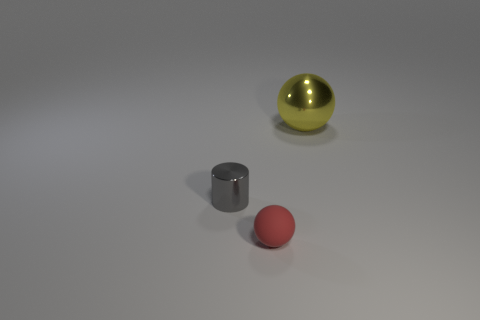Add 2 blue cylinders. How many objects exist? 5 Subtract all red balls. How many balls are left? 1 Subtract 2 spheres. How many spheres are left? 0 Subtract all gray metallic cylinders. Subtract all tiny matte balls. How many objects are left? 1 Add 2 big yellow balls. How many big yellow balls are left? 3 Add 1 large blue matte objects. How many large blue matte objects exist? 1 Subtract 1 gray cylinders. How many objects are left? 2 Subtract all spheres. How many objects are left? 1 Subtract all gray spheres. Subtract all brown cylinders. How many spheres are left? 2 